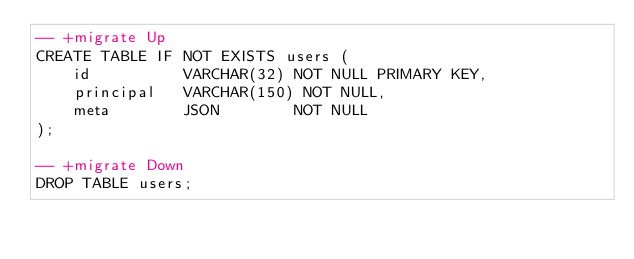Convert code to text. <code><loc_0><loc_0><loc_500><loc_500><_SQL_>-- +migrate Up
CREATE TABLE IF NOT EXISTS users (
    id          VARCHAR(32) NOT NULL PRIMARY KEY,
    principal   VARCHAR(150) NOT NULL,
    meta        JSON        NOT NULL
);

-- +migrate Down
DROP TABLE users;
</code> 